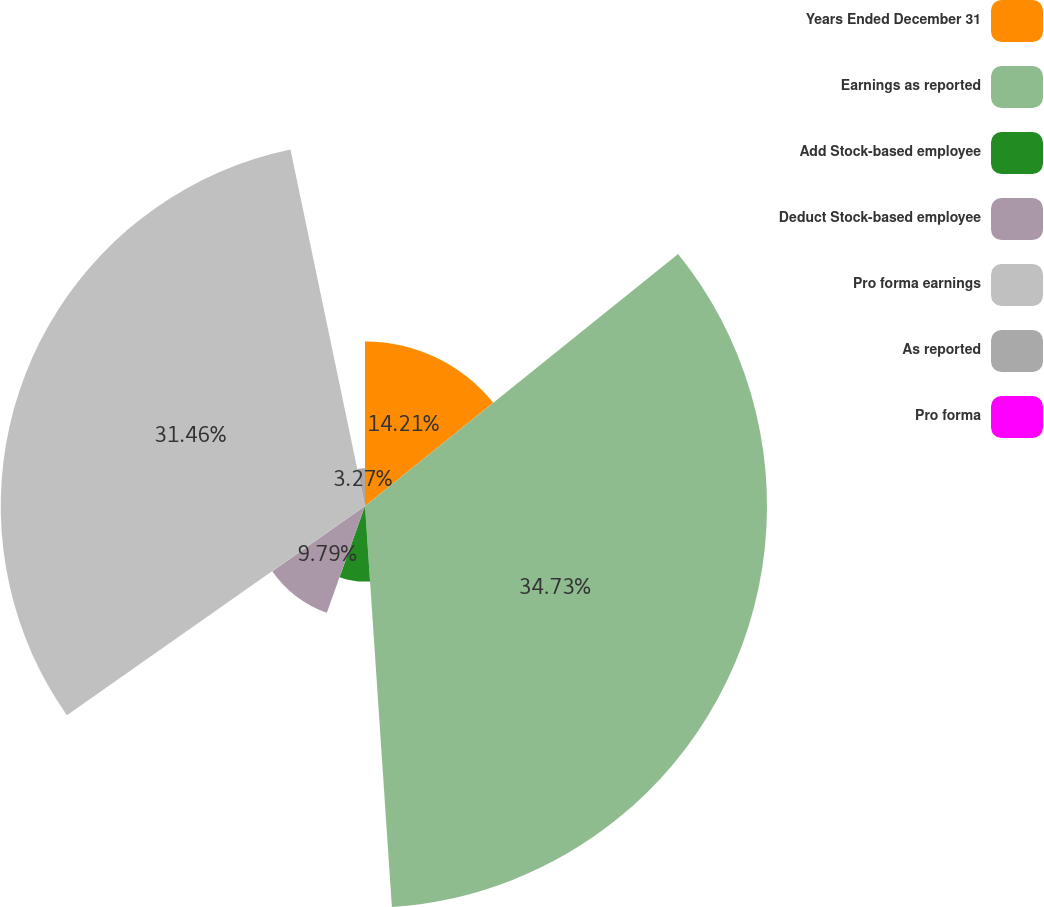Convert chart. <chart><loc_0><loc_0><loc_500><loc_500><pie_chart><fcel>Years Ended December 31<fcel>Earnings as reported<fcel>Add Stock-based employee<fcel>Deduct Stock-based employee<fcel>Pro forma earnings<fcel>As reported<fcel>Pro forma<nl><fcel>14.21%<fcel>34.72%<fcel>6.53%<fcel>9.79%<fcel>31.46%<fcel>3.27%<fcel>0.01%<nl></chart> 